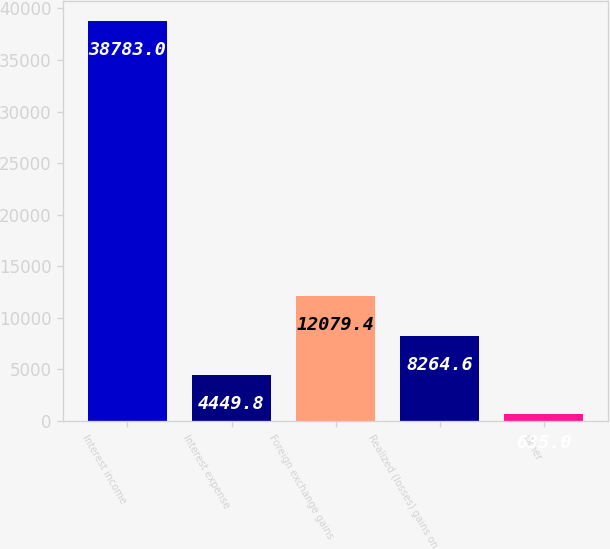Convert chart. <chart><loc_0><loc_0><loc_500><loc_500><bar_chart><fcel>Interest income<fcel>Interest expense<fcel>Foreign exchange gains<fcel>Realized (losses) gains on<fcel>Other<nl><fcel>38783<fcel>4449.8<fcel>12079.4<fcel>8264.6<fcel>635<nl></chart> 